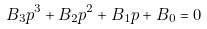<formula> <loc_0><loc_0><loc_500><loc_500>B _ { 3 } p ^ { 3 } + B _ { 2 } p ^ { 2 } + B _ { 1 } p + B _ { 0 } = 0</formula> 